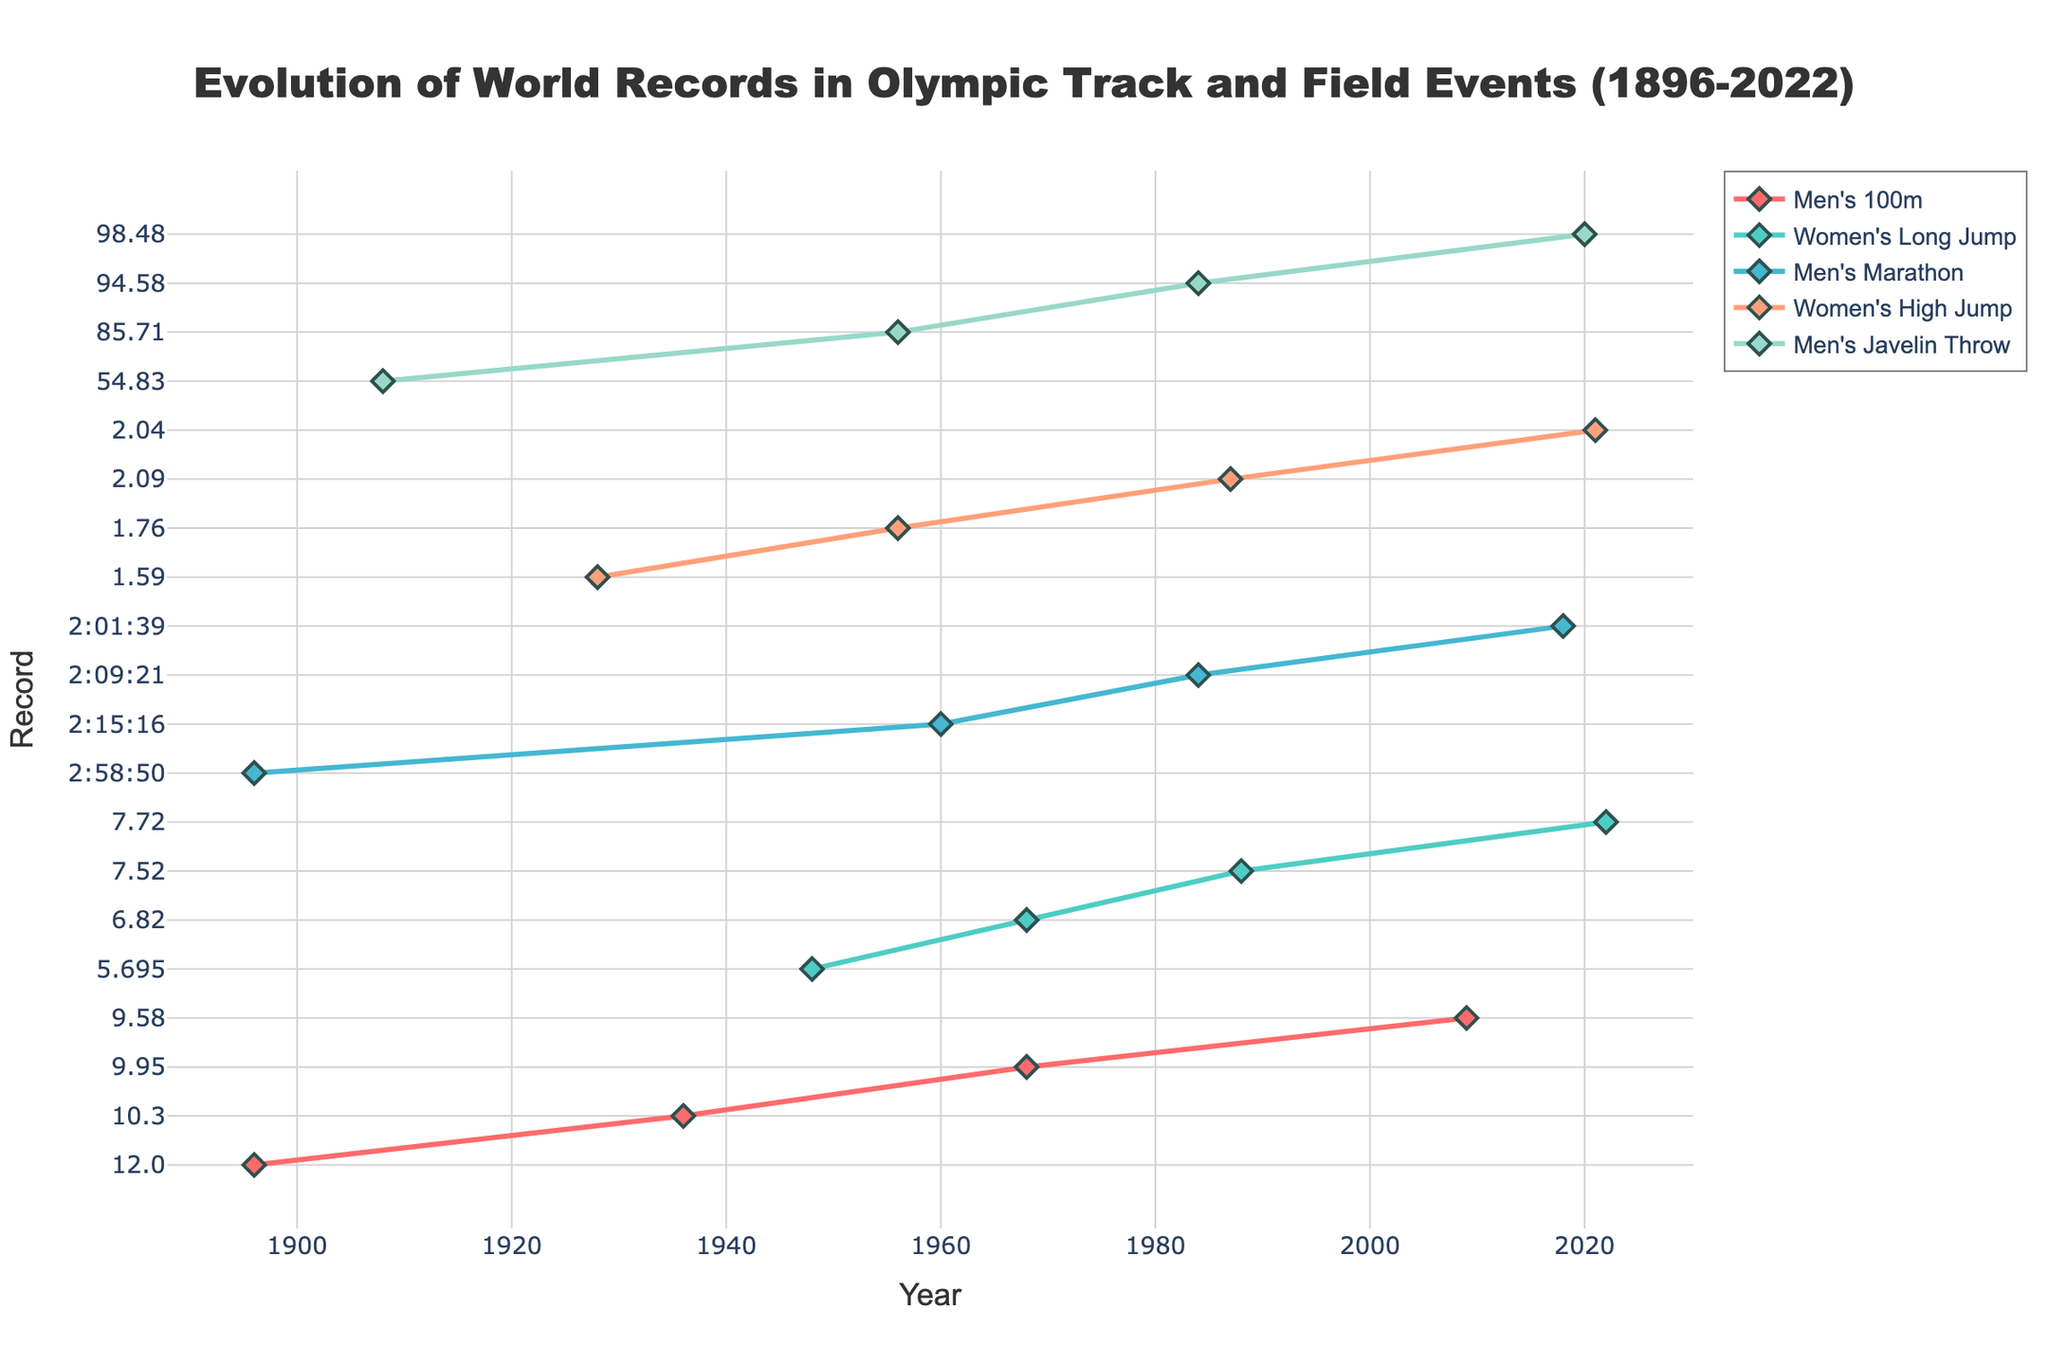What is the current world record for the Men's 100m event? By examining the latest point on the line corresponding to the Men's 100m event, you can see the record of 9.58 set by Usain Bolt in 2009.
Answer: 9.58 Which event showed the most significant improvement in the record from its earliest to latest year? Compare the difference between the earliest and latest records for each event. The Men’s Javelin Throw improved from 54.83m in 1908 to 98.48m in 2020, which is a change of 43.65m.
Answer: Men’s Javelin Throw When was the world record for the Women's High Jump set by Mariya Lasitskene? Look for the last data point in the Women's High Jump line, which shows 2.04m set by Mariya Lasitskene in 2021.
Answer: 2021 Between 1984 and 2022, which event demonstrated the least improvement in their record? Compute the change in records from 1984 to 2022 for each event. The Women's Long Jump improved from 7.52m in 1988 to 7.72m in 2022, a difference of 0.20m.
Answer: Women's Long Jump What is the difference between the world records in Men's 100m set in 1936 and 2009? Find the record for 1936 (10.3) and 2009 (9.58) for the Men's 100m on the line chart. Subtract 9.58 from 10.3 to get the difference.
Answer: 0.72 seconds How many different countries are represented in the record-holding athletes for the Men's Marathon? Check the country of each athlete who set a record in the Men's Marathon. List and count the unique countries: Greece, Ethiopia, Portugal, Kenya.
Answer: 4 Among the events presented, which one had the world record set by the earliest year? Identify the earliest year among all initial records in the data. The first year shown is 1896 for the Men’s 100m.
Answer: Men's 100m What is the average of the world records in the Women's High Jump event during the years provided? Sum the records of Women's High Jump at 1.59m, 1.76m, 2.09m, and 2.04m. Then, divide by the number of records (4). (1.59 + 1.76 + 2.09 + 2.04) / 4 = 1.87
Answer: 1.87 meters Which athlete set a new world record for the Men's Marathon in 1984, and what was the time? Look for the 1984 data point on the Men's Marathon line, which shows Carlos Lopes from Portugal with a time of 2:09:21.
Answer: Carlos Lopes, 2:09:21 Which event’s world record was last updated in the year 2020? Scan the data points for 2020. The Men's Javelin Throw shows a record update in 2020 by Johannes Vetter from Germany.
Answer: Men's Javelin Throw 